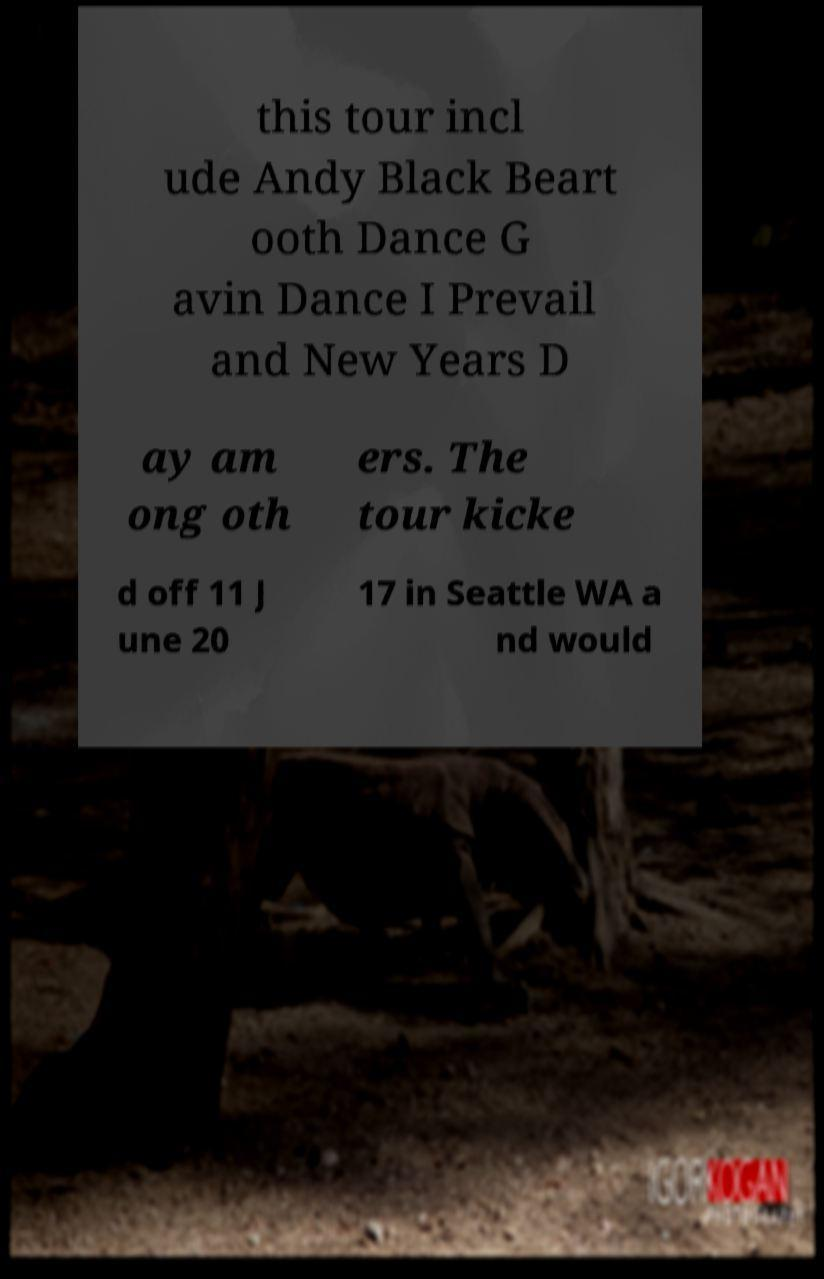There's text embedded in this image that I need extracted. Can you transcribe it verbatim? this tour incl ude Andy Black Beart ooth Dance G avin Dance I Prevail and New Years D ay am ong oth ers. The tour kicke d off 11 J une 20 17 in Seattle WA a nd would 